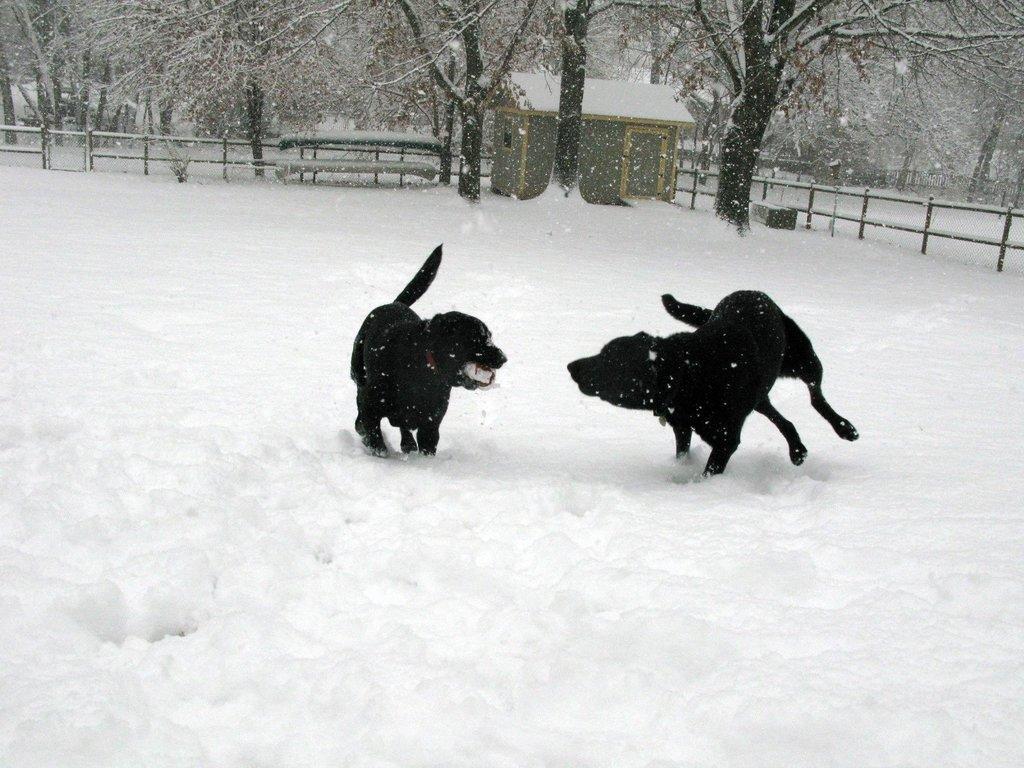Could you give a brief overview of what you see in this image? In the middle of the picture, we see two black dogs. At the bottom of the picture, we see snow. In the background, we see a hut, benches and the railing. There are trees in the background. 